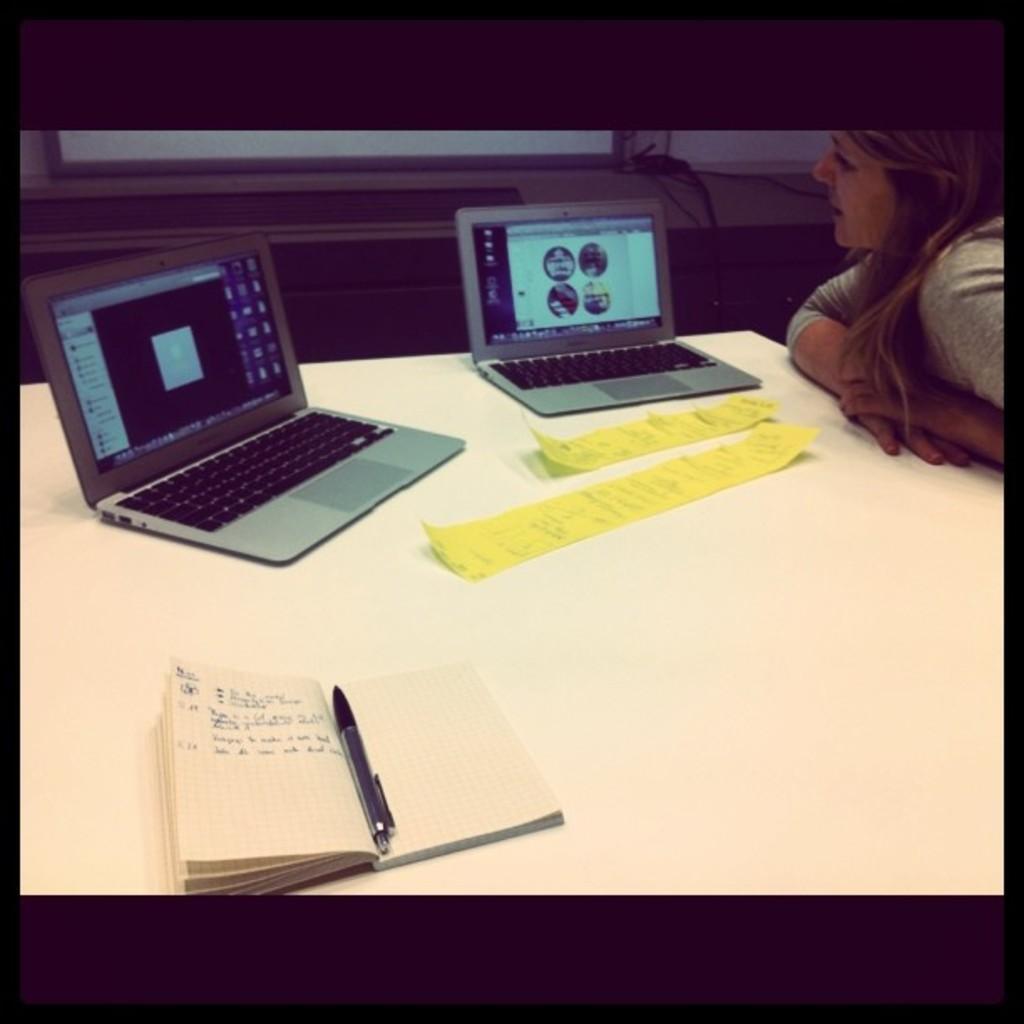In one or two sentences, can you explain what this image depicts? In this image, woman is seeing a laptop. She is there at the right side of the image. In the middle, We can see a white table. On top of the table, we can see book, pen, paper, 2 laptops. The background, we can see glass window. 